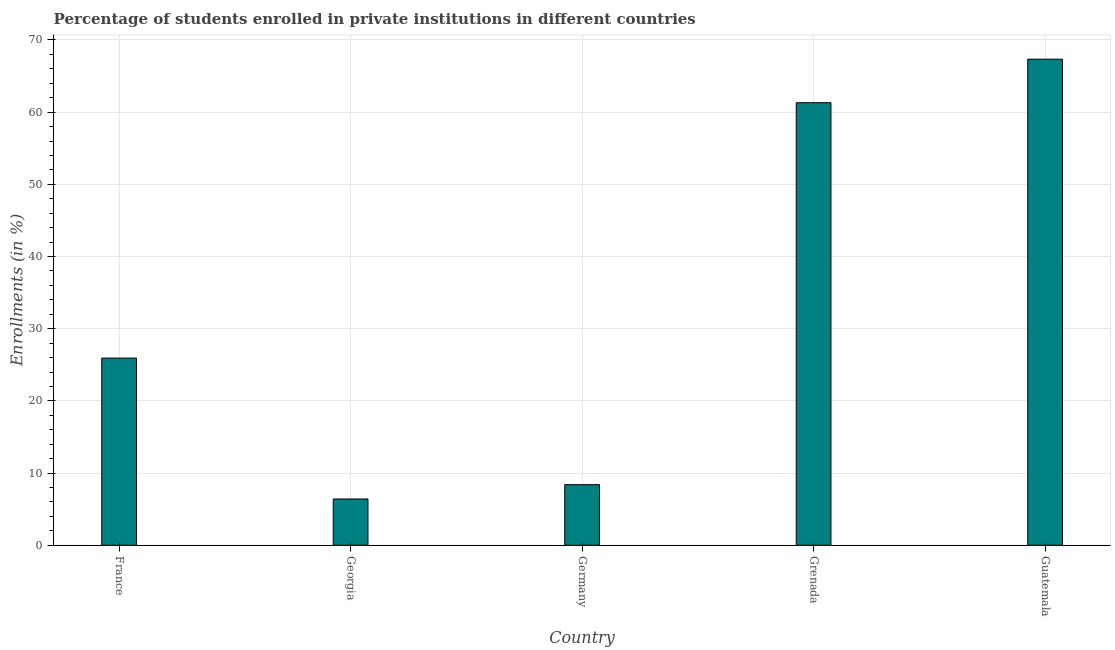Does the graph contain grids?
Your answer should be very brief. Yes. What is the title of the graph?
Your response must be concise. Percentage of students enrolled in private institutions in different countries. What is the label or title of the Y-axis?
Ensure brevity in your answer.  Enrollments (in %). What is the enrollments in private institutions in Germany?
Ensure brevity in your answer.  8.4. Across all countries, what is the maximum enrollments in private institutions?
Ensure brevity in your answer.  67.34. Across all countries, what is the minimum enrollments in private institutions?
Provide a succinct answer. 6.41. In which country was the enrollments in private institutions maximum?
Offer a terse response. Guatemala. In which country was the enrollments in private institutions minimum?
Give a very brief answer. Georgia. What is the sum of the enrollments in private institutions?
Keep it short and to the point. 169.39. What is the difference between the enrollments in private institutions in Georgia and Grenada?
Your response must be concise. -54.9. What is the average enrollments in private institutions per country?
Provide a short and direct response. 33.88. What is the median enrollments in private institutions?
Offer a terse response. 25.93. In how many countries, is the enrollments in private institutions greater than 16 %?
Your answer should be compact. 3. What is the ratio of the enrollments in private institutions in France to that in Grenada?
Your response must be concise. 0.42. Is the difference between the enrollments in private institutions in France and Germany greater than the difference between any two countries?
Your response must be concise. No. What is the difference between the highest and the second highest enrollments in private institutions?
Provide a succinct answer. 6.03. What is the difference between the highest and the lowest enrollments in private institutions?
Your answer should be very brief. 60.92. In how many countries, is the enrollments in private institutions greater than the average enrollments in private institutions taken over all countries?
Your answer should be compact. 2. How many countries are there in the graph?
Your answer should be compact. 5. What is the Enrollments (in %) of France?
Offer a terse response. 25.93. What is the Enrollments (in %) in Georgia?
Offer a very short reply. 6.41. What is the Enrollments (in %) of Germany?
Offer a very short reply. 8.4. What is the Enrollments (in %) of Grenada?
Make the answer very short. 61.31. What is the Enrollments (in %) in Guatemala?
Give a very brief answer. 67.34. What is the difference between the Enrollments (in %) in France and Georgia?
Your answer should be compact. 19.52. What is the difference between the Enrollments (in %) in France and Germany?
Make the answer very short. 17.54. What is the difference between the Enrollments (in %) in France and Grenada?
Keep it short and to the point. -35.38. What is the difference between the Enrollments (in %) in France and Guatemala?
Your response must be concise. -41.41. What is the difference between the Enrollments (in %) in Georgia and Germany?
Your response must be concise. -1.98. What is the difference between the Enrollments (in %) in Georgia and Grenada?
Give a very brief answer. -54.89. What is the difference between the Enrollments (in %) in Georgia and Guatemala?
Ensure brevity in your answer.  -60.92. What is the difference between the Enrollments (in %) in Germany and Grenada?
Ensure brevity in your answer.  -52.91. What is the difference between the Enrollments (in %) in Germany and Guatemala?
Keep it short and to the point. -58.94. What is the difference between the Enrollments (in %) in Grenada and Guatemala?
Offer a terse response. -6.03. What is the ratio of the Enrollments (in %) in France to that in Georgia?
Keep it short and to the point. 4.04. What is the ratio of the Enrollments (in %) in France to that in Germany?
Your answer should be very brief. 3.09. What is the ratio of the Enrollments (in %) in France to that in Grenada?
Give a very brief answer. 0.42. What is the ratio of the Enrollments (in %) in France to that in Guatemala?
Offer a very short reply. 0.39. What is the ratio of the Enrollments (in %) in Georgia to that in Germany?
Your answer should be compact. 0.76. What is the ratio of the Enrollments (in %) in Georgia to that in Grenada?
Your response must be concise. 0.1. What is the ratio of the Enrollments (in %) in Georgia to that in Guatemala?
Keep it short and to the point. 0.1. What is the ratio of the Enrollments (in %) in Germany to that in Grenada?
Your answer should be compact. 0.14. What is the ratio of the Enrollments (in %) in Grenada to that in Guatemala?
Your answer should be very brief. 0.91. 